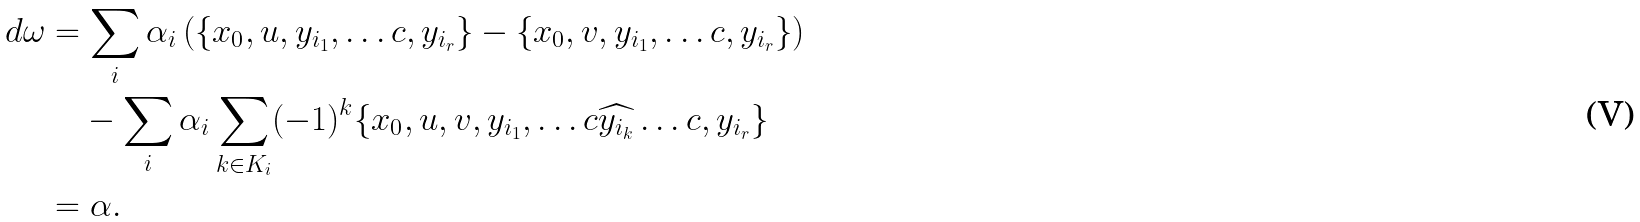<formula> <loc_0><loc_0><loc_500><loc_500>d \omega & = \sum _ { i } \alpha _ { i } \left ( \{ x _ { 0 } , u , y _ { i _ { 1 } } , \dots c , y _ { i _ { r } } \} - \{ x _ { 0 } , v , y _ { i _ { 1 } } , \dots c , y _ { i _ { r } } \} \right ) \\ & \quad - \sum _ { i } \alpha _ { i } \sum _ { k \in K _ { i } } ( - 1 ) ^ { k } \{ x _ { 0 } , u , v , y _ { i _ { 1 } } , \dots c \widehat { y _ { i _ { k } } } \dots c , y _ { i _ { r } } \} \\ & = \alpha .</formula> 